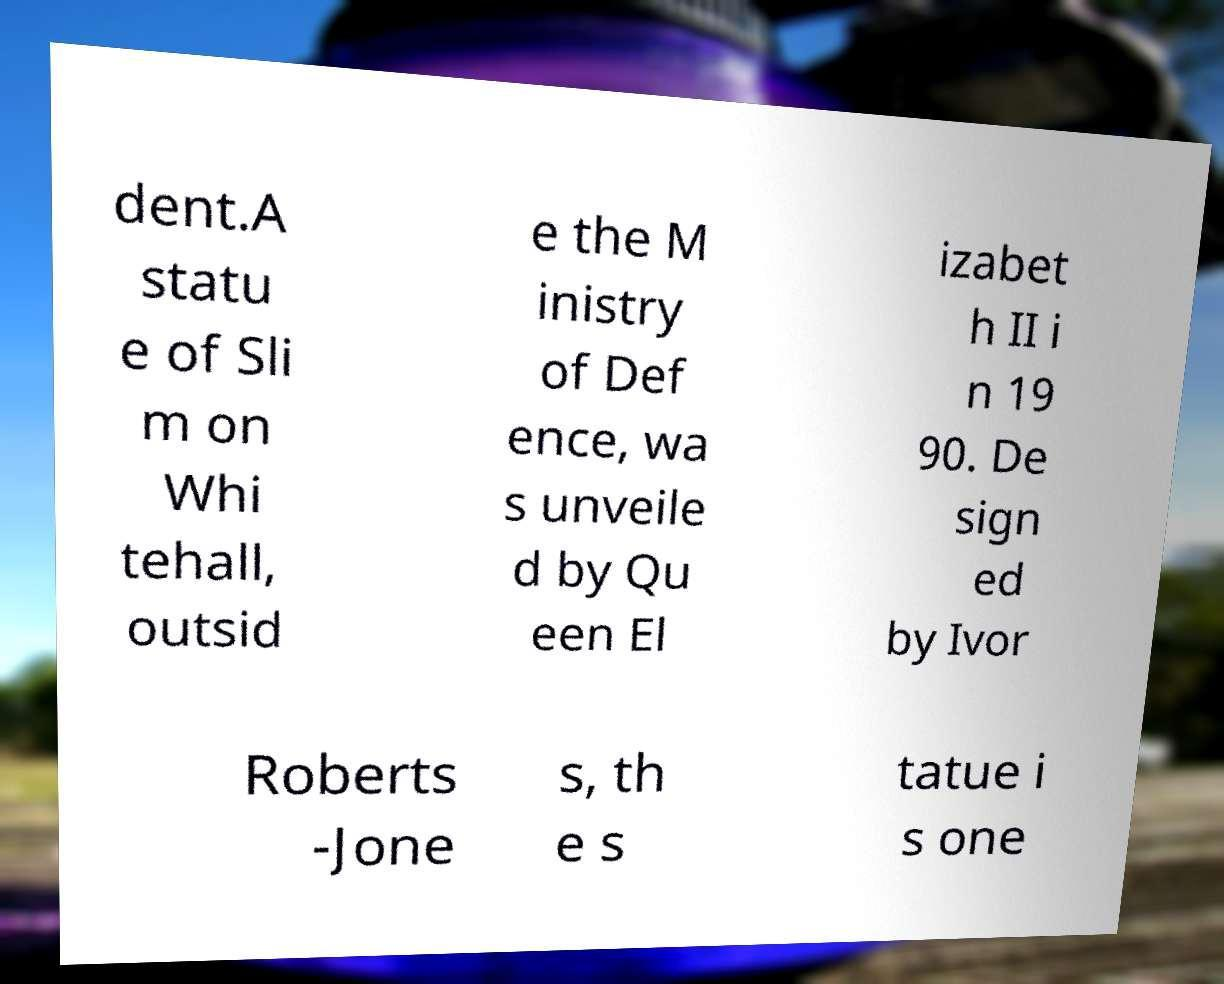For documentation purposes, I need the text within this image transcribed. Could you provide that? dent.A statu e of Sli m on Whi tehall, outsid e the M inistry of Def ence, wa s unveile d by Qu een El izabet h II i n 19 90. De sign ed by Ivor Roberts -Jone s, th e s tatue i s one 